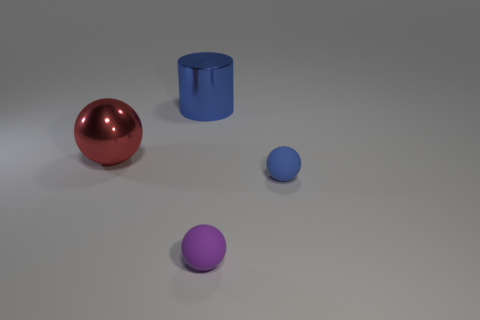Are there any purple spheres behind the blue object that is in front of the metal thing in front of the big blue cylinder?
Your answer should be very brief. No. How many small objects are either purple rubber things or spheres?
Provide a short and direct response. 2. There is a shiny cylinder that is the same size as the metal sphere; what is its color?
Offer a terse response. Blue. There is a blue matte thing; what number of small blue rubber things are behind it?
Your answer should be compact. 0. Is there a purple ball made of the same material as the tiny blue sphere?
Offer a terse response. Yes. What is the shape of the tiny matte thing that is the same color as the shiny cylinder?
Your answer should be very brief. Sphere. What color is the large object to the right of the large shiny sphere?
Your answer should be compact. Blue. Are there an equal number of red balls that are right of the big red object and small purple matte balls on the left side of the blue metallic cylinder?
Your answer should be compact. Yes. What material is the tiny ball that is left of the blue thing that is on the right side of the blue shiny cylinder?
Provide a succinct answer. Rubber. What number of objects are red metallic things or things that are behind the tiny purple object?
Keep it short and to the point. 3. 